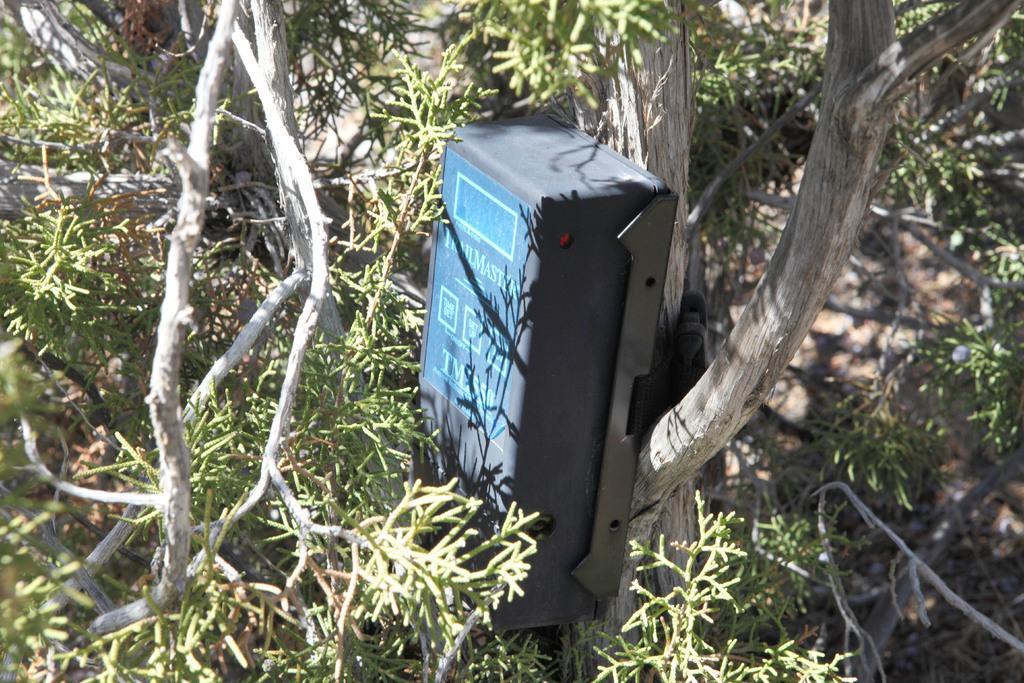Can you describe this image briefly? We can see box on the wooden surface and we can see branches and leaves. 